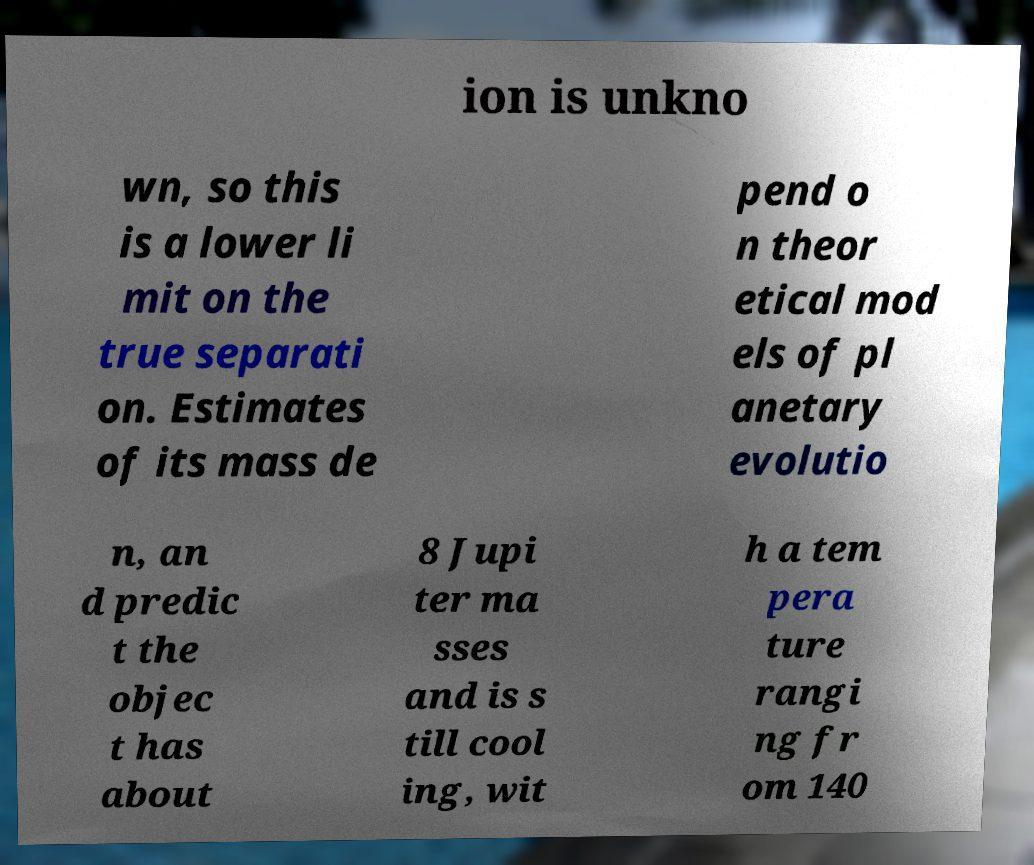Please read and relay the text visible in this image. What does it say? ion is unkno wn, so this is a lower li mit on the true separati on. Estimates of its mass de pend o n theor etical mod els of pl anetary evolutio n, an d predic t the objec t has about 8 Jupi ter ma sses and is s till cool ing, wit h a tem pera ture rangi ng fr om 140 